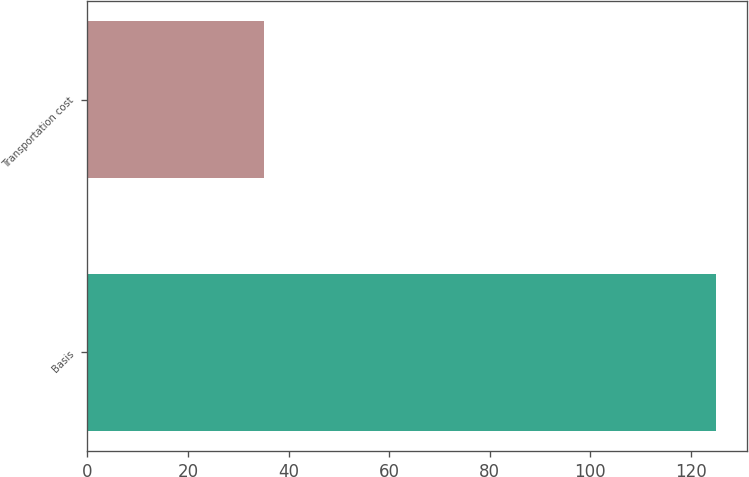Convert chart to OTSL. <chart><loc_0><loc_0><loc_500><loc_500><bar_chart><fcel>Basis<fcel>Transportation cost<nl><fcel>125<fcel>35.1<nl></chart> 